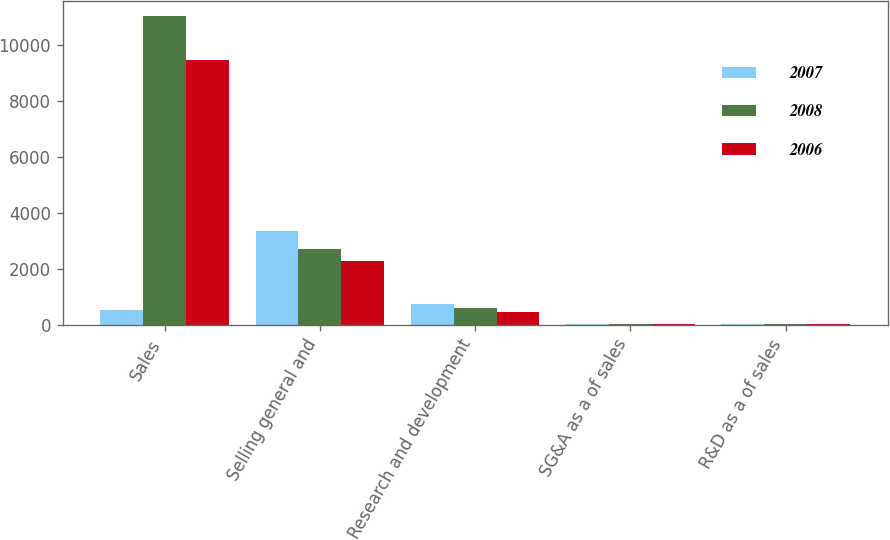<chart> <loc_0><loc_0><loc_500><loc_500><stacked_bar_chart><ecel><fcel>Sales<fcel>Selling general and<fcel>Research and development<fcel>SG&A as a of sales<fcel>R&D as a of sales<nl><fcel>2007<fcel>520.7<fcel>3345.3<fcel>725.4<fcel>26.3<fcel>5.7<nl><fcel>2008<fcel>11025.9<fcel>2713.1<fcel>601.4<fcel>24.6<fcel>5.5<nl><fcel>2006<fcel>9466.1<fcel>2273.2<fcel>440<fcel>24<fcel>4.6<nl></chart> 